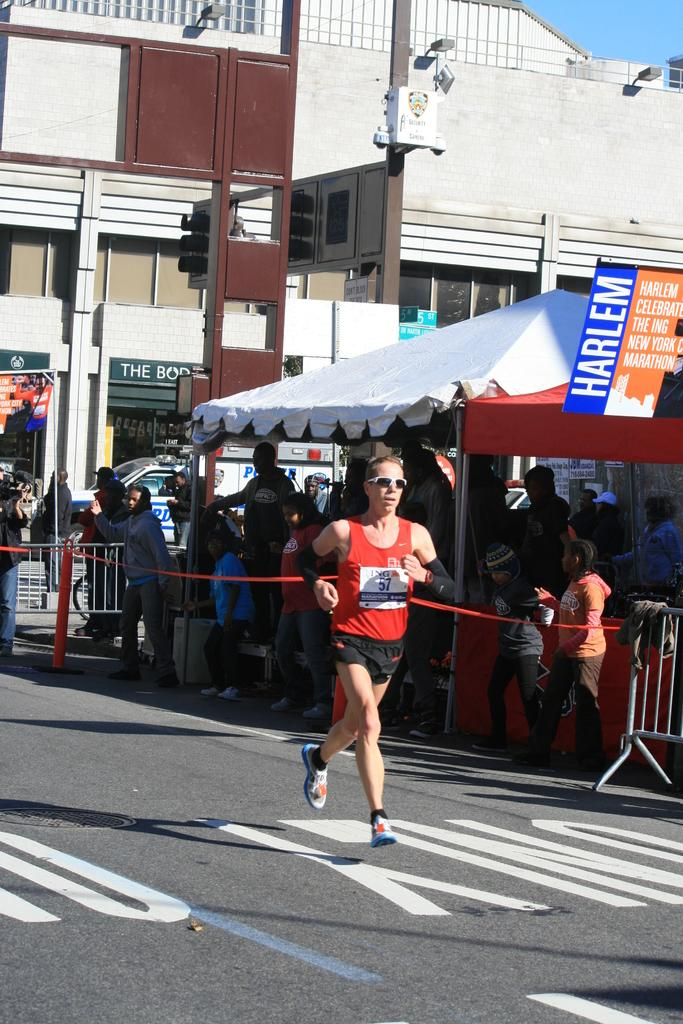What is the person in the image doing? There is a person running on the road in the image. What can be seen on the right side of the road? There is a tent on the right side of the road. What are the people under the tent doing? There are people standing under the tent. What is visible at the top of the image? The sky and a building are visible at the top of the image. What type of rail is present in the image? There is no rail present in the image. What role do the people under the tent play in relation to the person running on the road? The provided facts do not indicate any relationship between the people under the tent and the person running on the road. 